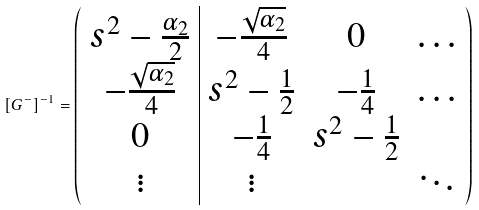Convert formula to latex. <formula><loc_0><loc_0><loc_500><loc_500>\left [ { G } ^ { - } \right ] ^ { - 1 } = \left ( \begin{array} { c | c c c } s ^ { 2 } - \frac { \alpha _ { 2 } } { 2 } & - \frac { \sqrt { \alpha _ { 2 } } } { 4 } & 0 & \dots \\ - \frac { \sqrt { \alpha _ { 2 } } } { 4 } & s ^ { 2 } - \frac { 1 } { 2 } & - \frac { 1 } { 4 } & \dots \\ 0 & - \frac { 1 } { 4 } & s ^ { 2 } - \frac { 1 } { 2 } & \\ \vdots & \vdots & & \ddots \end{array} \right )</formula> 